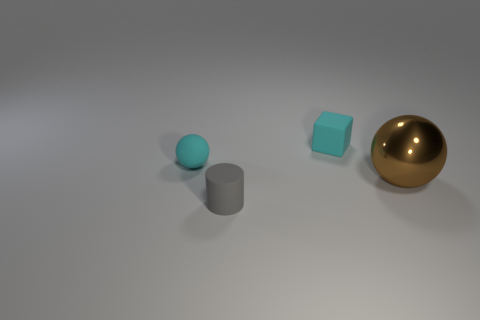Imagine these objects are part of a game, how would it be played? If these objects were part of a game, it might be a tactile puzzle where players need to rearrange the pieces based on hints given, such as organizing them by weight, color, or material. Alternatively, the game could involve challenges like moving the objects from one location to another without touching them directly, using tools, or even creating structures that balance them in unique ways. The mix of shapes and textures would provide a variety of challenges for the players. 